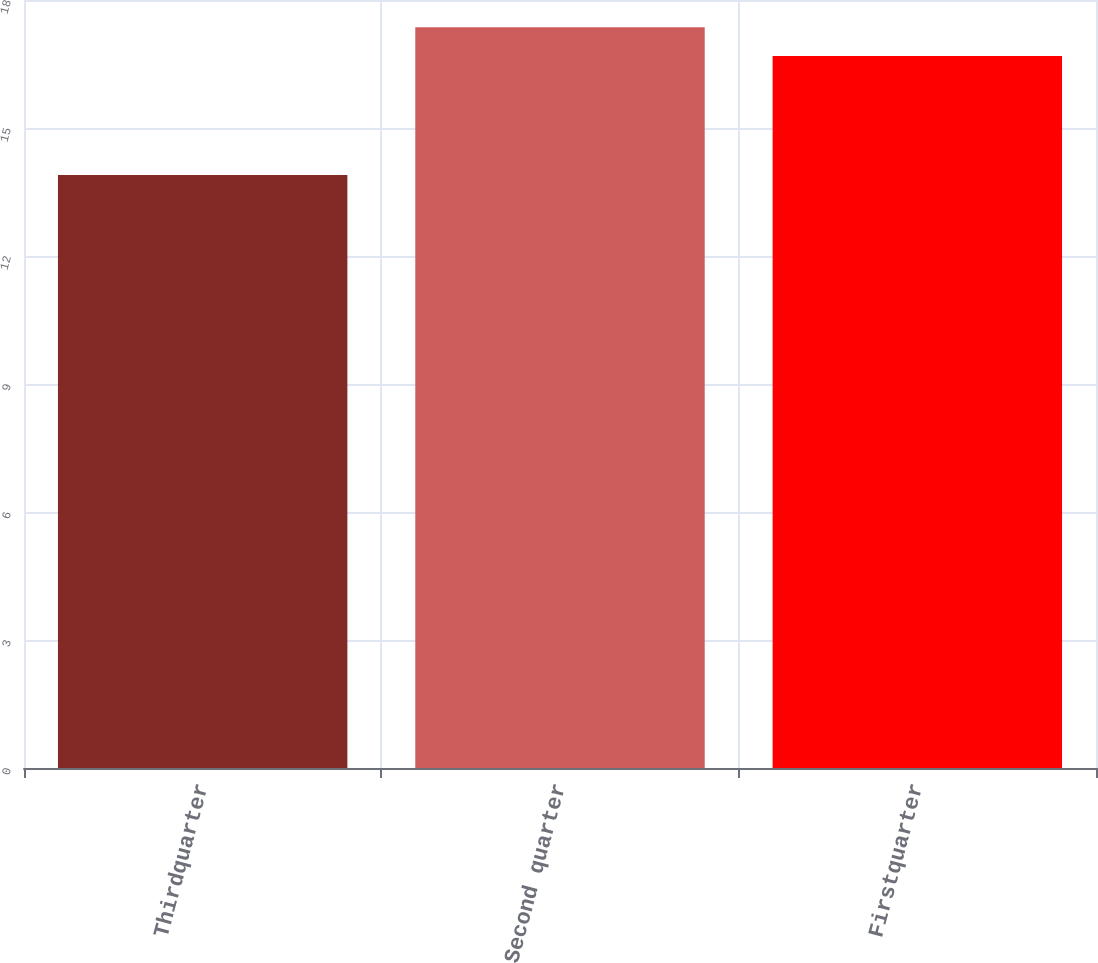Convert chart. <chart><loc_0><loc_0><loc_500><loc_500><bar_chart><fcel>Thirdquarter<fcel>Second quarter<fcel>Firstquarter<nl><fcel>13.9<fcel>17.36<fcel>16.69<nl></chart> 